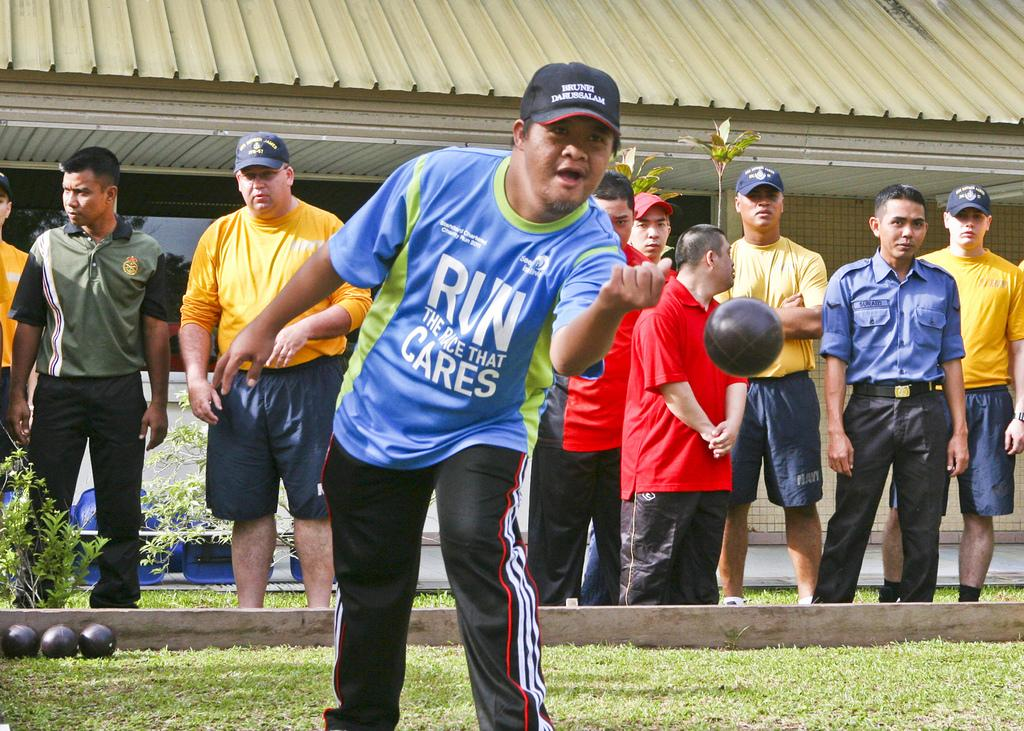<image>
Offer a succinct explanation of the picture presented. guy with run the race that cares shirt tossing a ball 